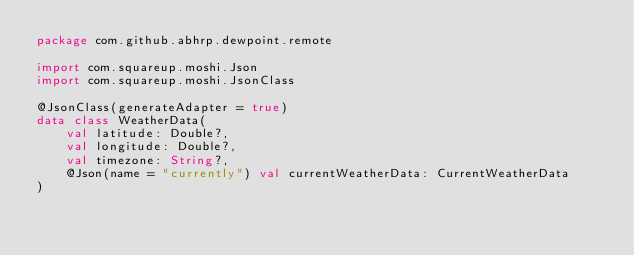Convert code to text. <code><loc_0><loc_0><loc_500><loc_500><_Kotlin_>package com.github.abhrp.dewpoint.remote

import com.squareup.moshi.Json
import com.squareup.moshi.JsonClass

@JsonClass(generateAdapter = true)
data class WeatherData(
    val latitude: Double?,
    val longitude: Double?,
    val timezone: String?,
    @Json(name = "currently") val currentWeatherData: CurrentWeatherData
)</code> 